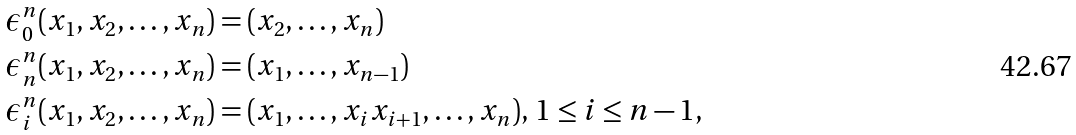Convert formula to latex. <formula><loc_0><loc_0><loc_500><loc_500>& \epsilon _ { 0 } ^ { n } ( x _ { 1 } , x _ { 2 } , \dots , x _ { n } ) = ( x _ { 2 } , \dots , x _ { n } ) \\ & \epsilon _ { n } ^ { n } ( x _ { 1 } , x _ { 2 } , \dots , x _ { n } ) = ( x _ { 1 } , \dots , x _ { n - 1 } ) \\ & \epsilon _ { i } ^ { n } ( x _ { 1 } , x _ { 2 } , \dots , x _ { n } ) = ( x _ { 1 } , \dots , x _ { i } x _ { i + 1 } , \dots , x _ { n } ) , \, 1 \leq i \leq n - 1 ,</formula> 